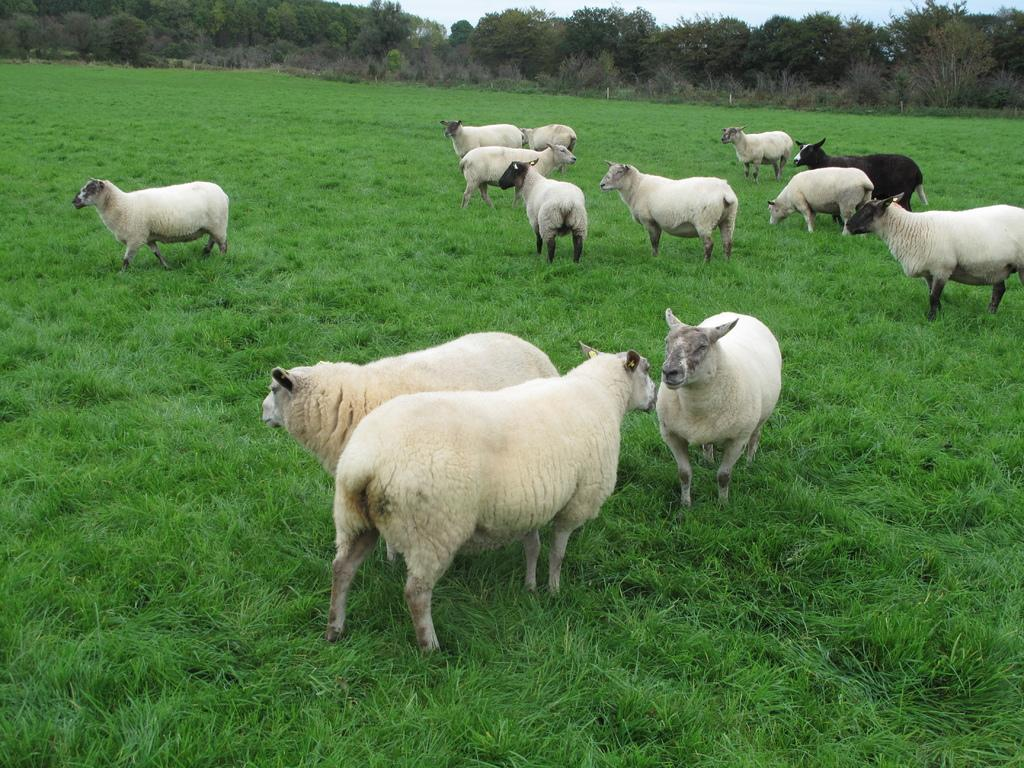What animals are present in the image? There are sheeps in the image. Where are the sheeps located? The sheeps are on the grass. What can be seen in the background of the image? There are trees, plants, grass, and the sky visible in the background of the image. What type of trees can be seen in the cemetery in the image? There is no cemetery present in the image; it features sheeps on the grass with trees, plants, grass, and the sky visible in the background. 